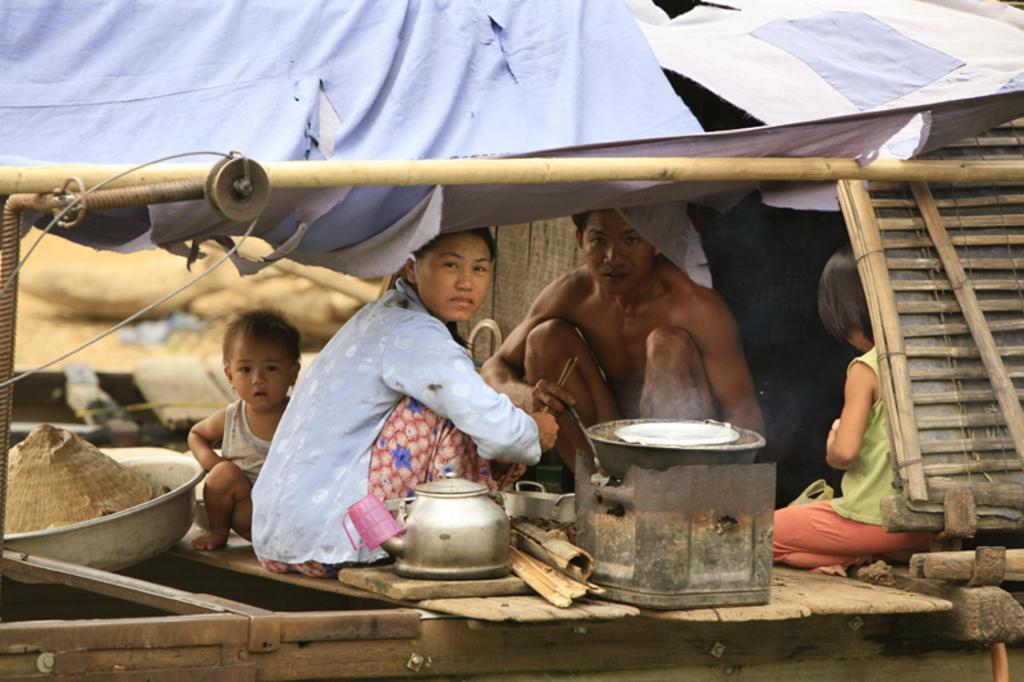Who is present in the image? There are people in the image. Can you describe the age group of some individuals in the image? There are children in the image. What objects can be seen in the image that might be used for eating or cooking? There are utensils in the image. How would you describe the quality of the image in the background? The image is blurry in the background. What type of gun can be seen in the image? There is no gun present in the image. How many ears of corn are visible in the image? There is no corn present in the image. 